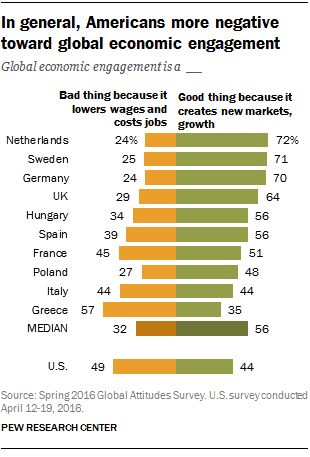Draw attention to some important aspects in this diagram. Yes, the value of bad things in the U.S. is due to lower wages and leads to job losses, which is higher than in the Netherlands. The value of the smallest green bar is 35. 